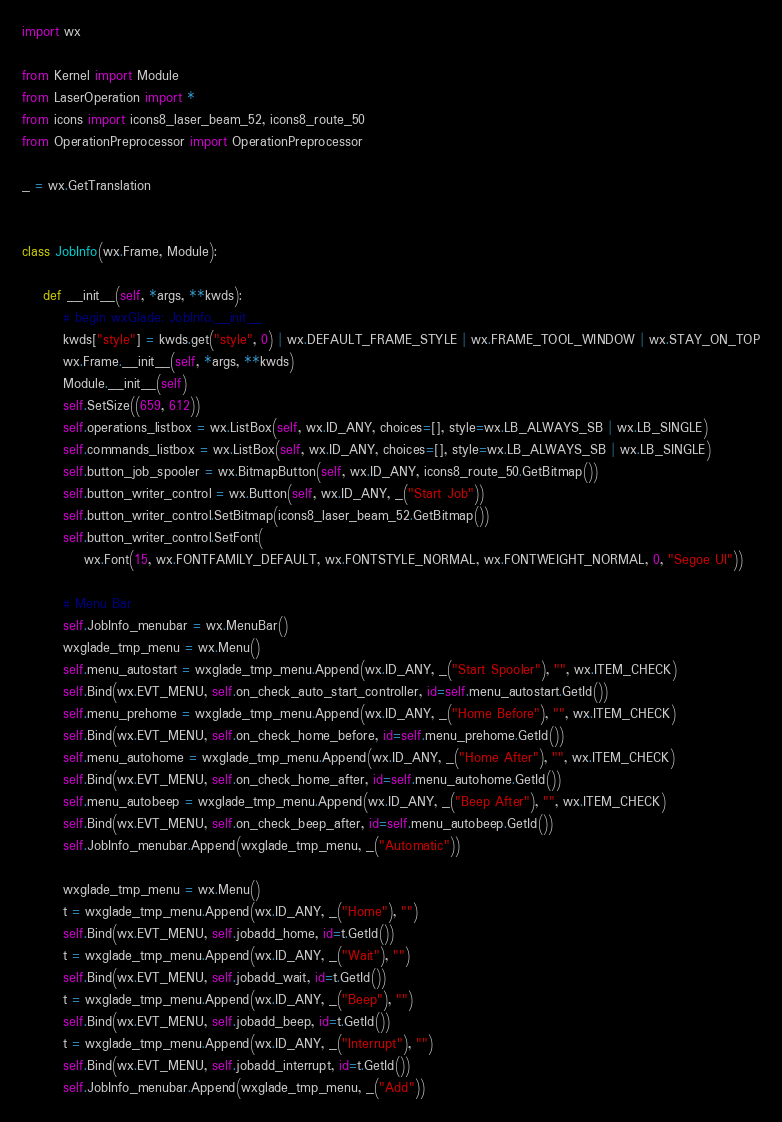<code> <loc_0><loc_0><loc_500><loc_500><_Python_>import wx

from Kernel import Module
from LaserOperation import *
from icons import icons8_laser_beam_52, icons8_route_50
from OperationPreprocessor import OperationPreprocessor

_ = wx.GetTranslation


class JobInfo(wx.Frame, Module):

    def __init__(self, *args, **kwds):
        # begin wxGlade: JobInfo.__init__
        kwds["style"] = kwds.get("style", 0) | wx.DEFAULT_FRAME_STYLE | wx.FRAME_TOOL_WINDOW | wx.STAY_ON_TOP
        wx.Frame.__init__(self, *args, **kwds)
        Module.__init__(self)
        self.SetSize((659, 612))
        self.operations_listbox = wx.ListBox(self, wx.ID_ANY, choices=[], style=wx.LB_ALWAYS_SB | wx.LB_SINGLE)
        self.commands_listbox = wx.ListBox(self, wx.ID_ANY, choices=[], style=wx.LB_ALWAYS_SB | wx.LB_SINGLE)
        self.button_job_spooler = wx.BitmapButton(self, wx.ID_ANY, icons8_route_50.GetBitmap())
        self.button_writer_control = wx.Button(self, wx.ID_ANY, _("Start Job"))
        self.button_writer_control.SetBitmap(icons8_laser_beam_52.GetBitmap())
        self.button_writer_control.SetFont(
            wx.Font(15, wx.FONTFAMILY_DEFAULT, wx.FONTSTYLE_NORMAL, wx.FONTWEIGHT_NORMAL, 0, "Segoe UI"))

        # Menu Bar
        self.JobInfo_menubar = wx.MenuBar()
        wxglade_tmp_menu = wx.Menu()
        self.menu_autostart = wxglade_tmp_menu.Append(wx.ID_ANY, _("Start Spooler"), "", wx.ITEM_CHECK)
        self.Bind(wx.EVT_MENU, self.on_check_auto_start_controller, id=self.menu_autostart.GetId())
        self.menu_prehome = wxglade_tmp_menu.Append(wx.ID_ANY, _("Home Before"), "", wx.ITEM_CHECK)
        self.Bind(wx.EVT_MENU, self.on_check_home_before, id=self.menu_prehome.GetId())
        self.menu_autohome = wxglade_tmp_menu.Append(wx.ID_ANY, _("Home After"), "", wx.ITEM_CHECK)
        self.Bind(wx.EVT_MENU, self.on_check_home_after, id=self.menu_autohome.GetId())
        self.menu_autobeep = wxglade_tmp_menu.Append(wx.ID_ANY, _("Beep After"), "", wx.ITEM_CHECK)
        self.Bind(wx.EVT_MENU, self.on_check_beep_after, id=self.menu_autobeep.GetId())
        self.JobInfo_menubar.Append(wxglade_tmp_menu, _("Automatic"))

        wxglade_tmp_menu = wx.Menu()
        t = wxglade_tmp_menu.Append(wx.ID_ANY, _("Home"), "")
        self.Bind(wx.EVT_MENU, self.jobadd_home, id=t.GetId())
        t = wxglade_tmp_menu.Append(wx.ID_ANY, _("Wait"), "")
        self.Bind(wx.EVT_MENU, self.jobadd_wait, id=t.GetId())
        t = wxglade_tmp_menu.Append(wx.ID_ANY, _("Beep"), "")
        self.Bind(wx.EVT_MENU, self.jobadd_beep, id=t.GetId())
        t = wxglade_tmp_menu.Append(wx.ID_ANY, _("Interrupt"), "")
        self.Bind(wx.EVT_MENU, self.jobadd_interrupt, id=t.GetId())
        self.JobInfo_menubar.Append(wxglade_tmp_menu, _("Add"))</code> 